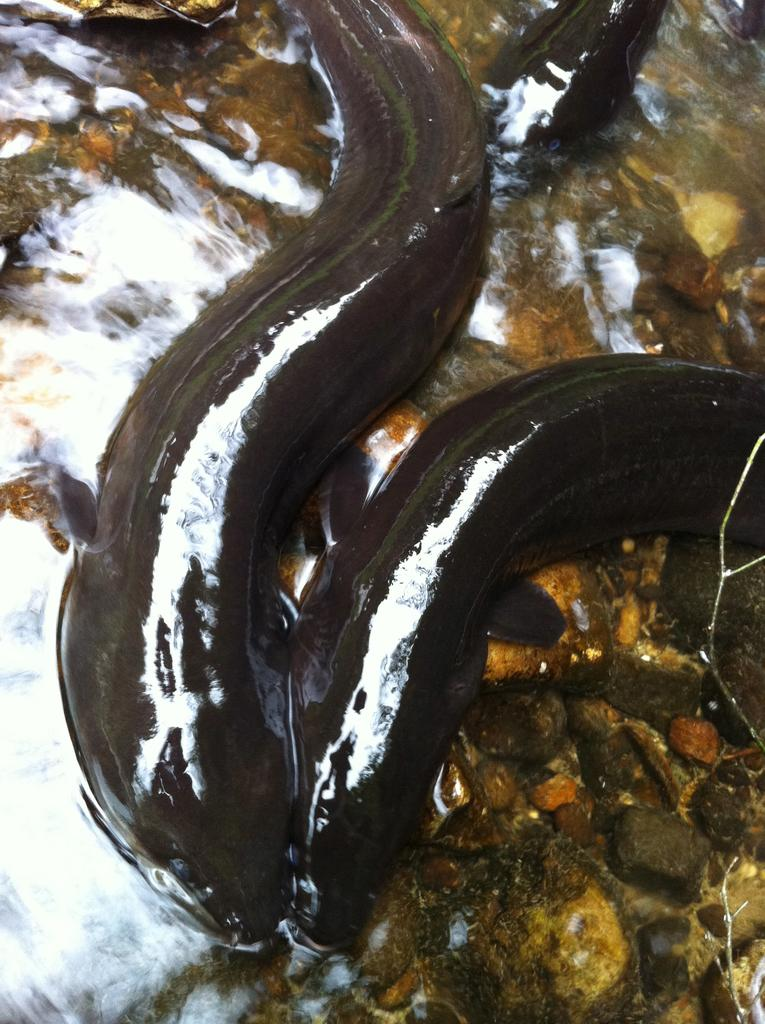What type of animals can be seen in the image? There are fishes in the image. What is at the bottom of the image? There is water at the bottom of the image. What other objects can be seen in the image? There are stones visible in the image. What type of loaf is being used as a doorstop in the image? There is no loaf present in the image; it features fishes, water, and stones. 